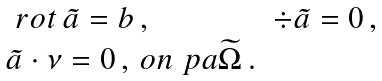<formula> <loc_0><loc_0><loc_500><loc_500>\begin{array} { l l } \ r o t \, { \tilde { a } } = b \, , \, & \div { \tilde { a } } = 0 \, , \, \\ { \tilde { a } } \cdot \nu = 0 \, , \, o n \ p a { \widetilde { \Omega } } \, . \end{array}</formula> 